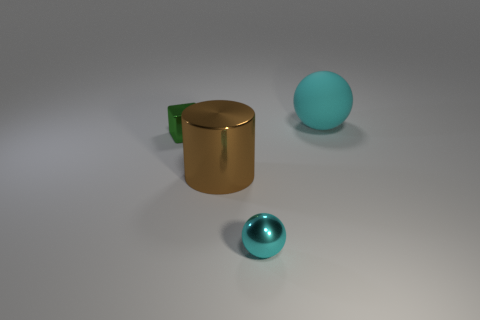Is the number of shiny spheres that are on the left side of the big rubber sphere greater than the number of tiny cyan balls that are behind the small cyan metal object?
Keep it short and to the point. Yes. There is another thing that is the same size as the rubber object; what is it made of?
Your answer should be very brief. Metal. What number of small objects are either green metal blocks or yellow balls?
Provide a short and direct response. 1. Does the big cyan rubber thing have the same shape as the brown object?
Your answer should be very brief. No. How many spheres are behind the metallic ball and left of the big matte ball?
Keep it short and to the point. 0. Is there any other thing that is the same color as the small sphere?
Your answer should be compact. Yes. There is a small cyan thing that is the same material as the green thing; what shape is it?
Your answer should be compact. Sphere. Do the cylinder and the cyan rubber thing have the same size?
Give a very brief answer. Yes. Does the thing left of the cylinder have the same material as the brown thing?
Provide a succinct answer. Yes. Are there any other things that are made of the same material as the large cyan object?
Offer a terse response. No. 